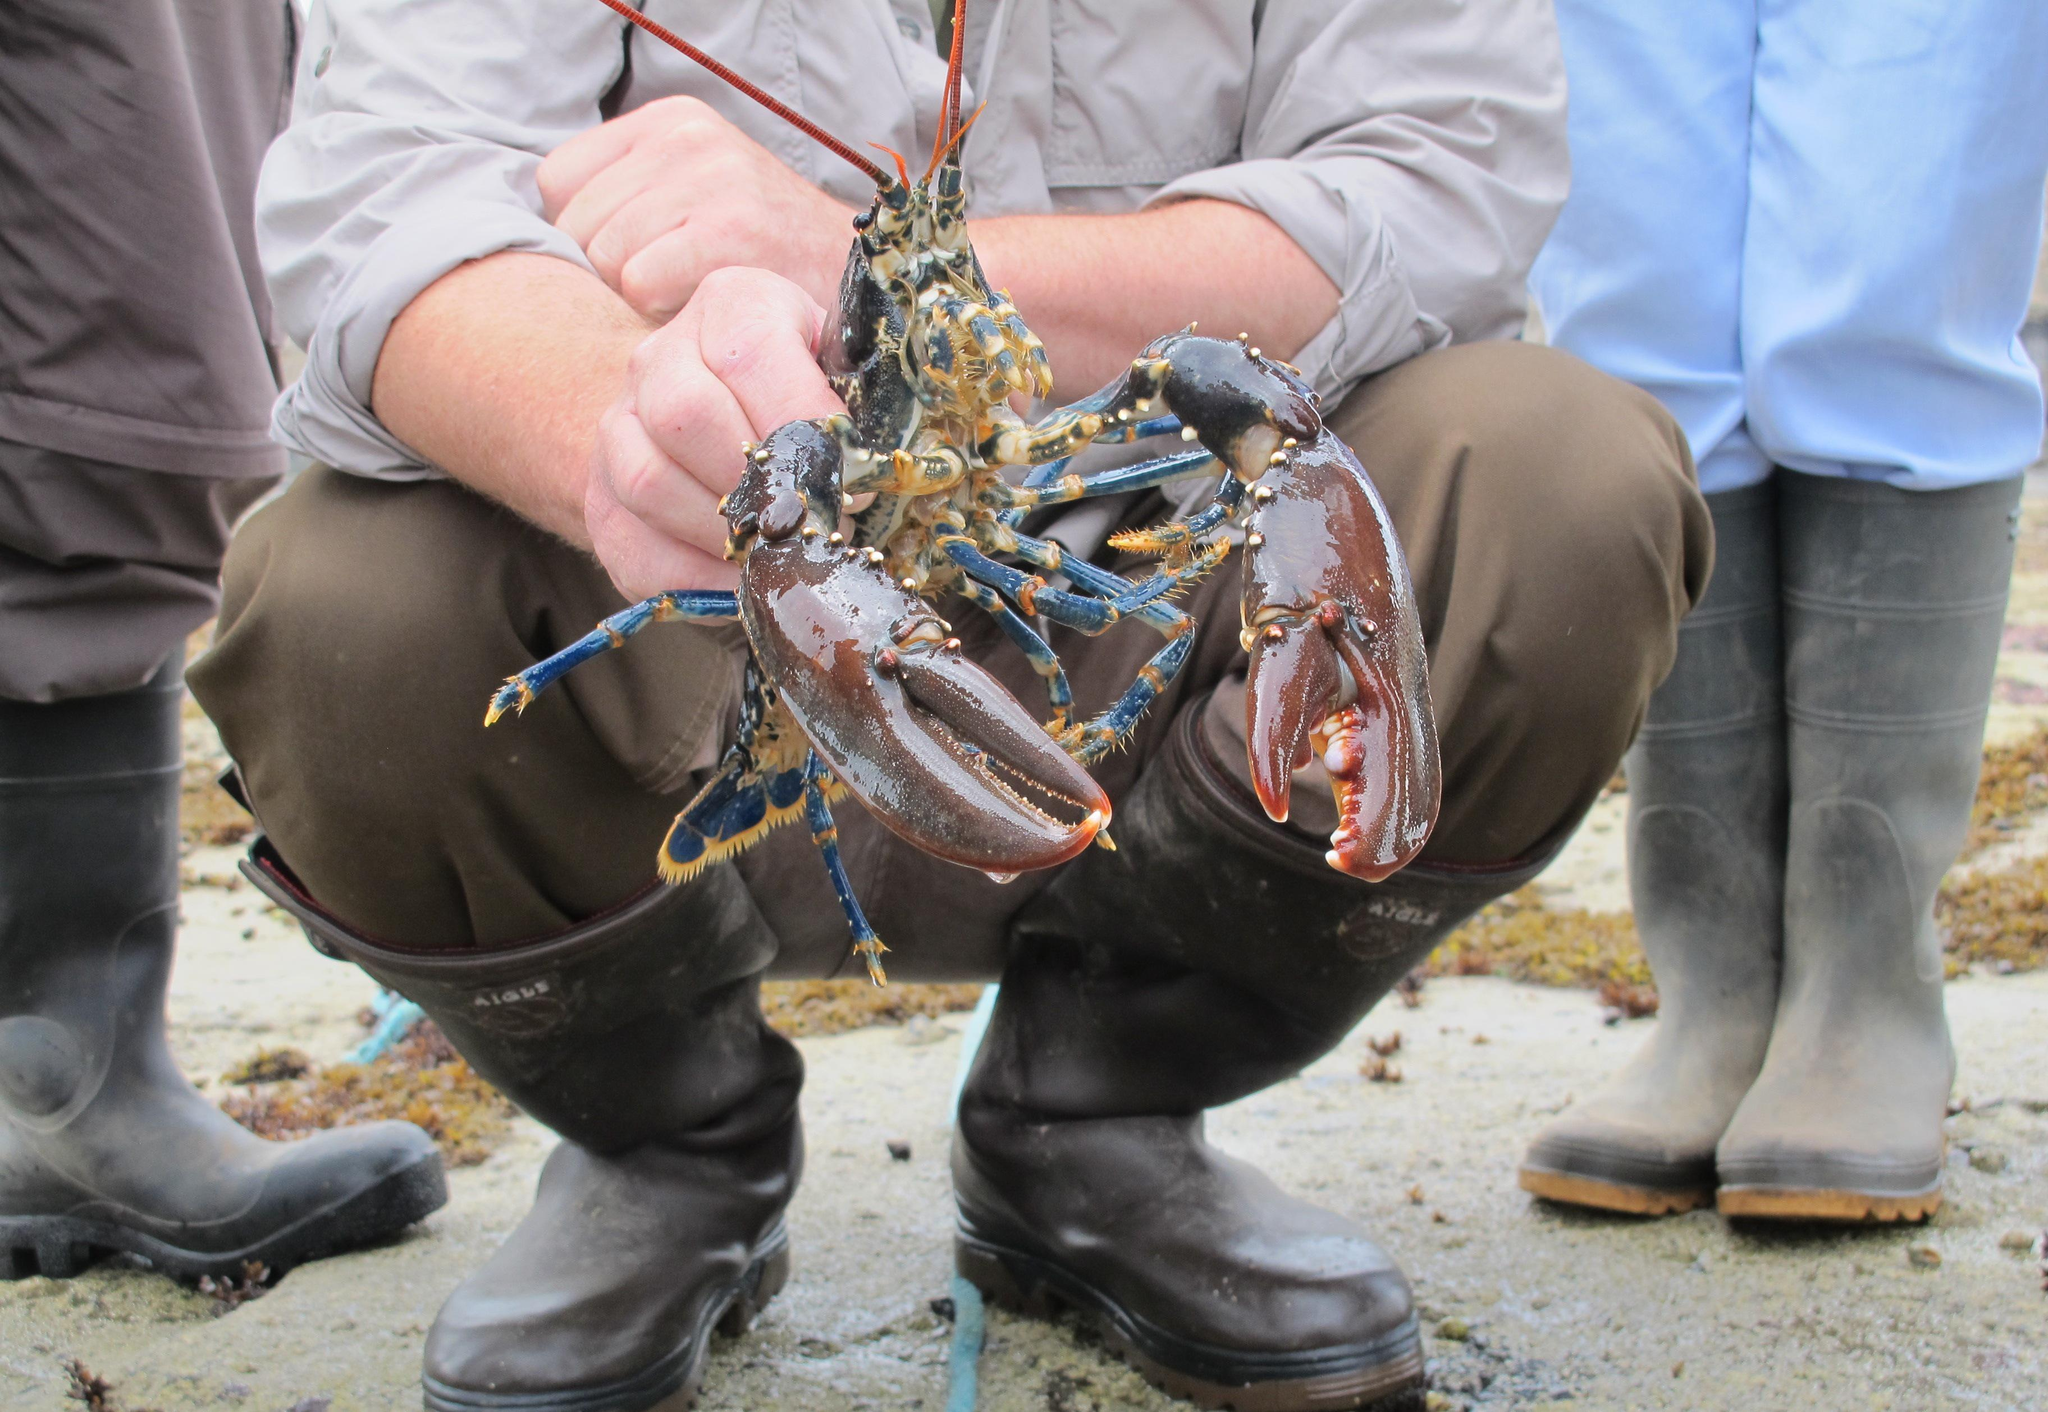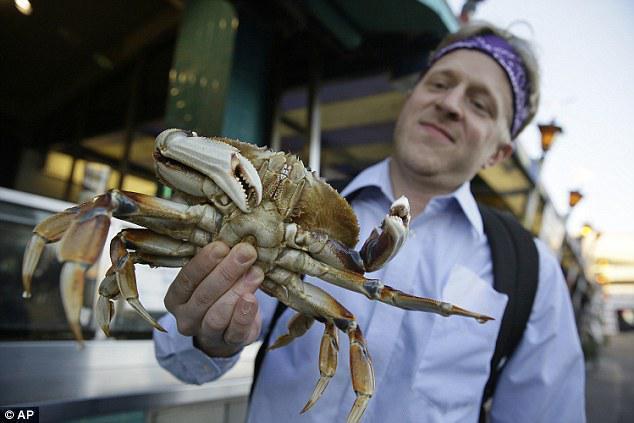The first image is the image on the left, the second image is the image on the right. Analyze the images presented: Is the assertion "In the right image, a man is holding a crab up belly-side forward in one bare hand." valid? Answer yes or no. Yes. The first image is the image on the left, the second image is the image on the right. Analyze the images presented: Is the assertion "A man is holding one of the crabs at chest height in one of the images." valid? Answer yes or no. Yes. 